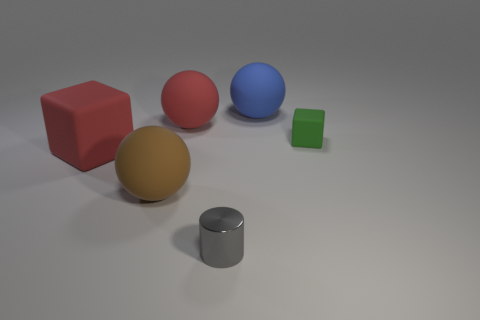Add 2 small matte blocks. How many objects exist? 8 Subtract all cubes. How many objects are left? 4 Subtract 1 green cubes. How many objects are left? 5 Subtract all brown balls. Subtract all large red matte spheres. How many objects are left? 4 Add 2 big brown balls. How many big brown balls are left? 3 Add 4 tiny gray metallic objects. How many tiny gray metallic objects exist? 5 